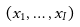Convert formula to latex. <formula><loc_0><loc_0><loc_500><loc_500>( x _ { 1 } , \dots , x _ { I } )</formula> 